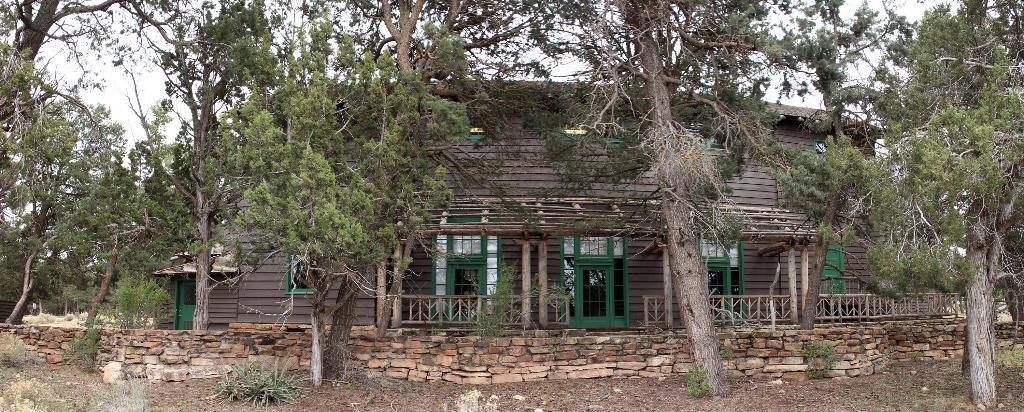What type of vegetation can be seen in the image? There are plants and trees in the image. What type of structure is visible in the image? There is a house in the image. What architectural feature can be seen in the image? There is a rock wall in the image. What is visible at the top of the image? The sky is visible at the top of the image. Can you see a pig feeling shame in the image? There is no pig or any indication of shame present in the image. Is there a monkey visible in the image? There is no monkey present in the image. 